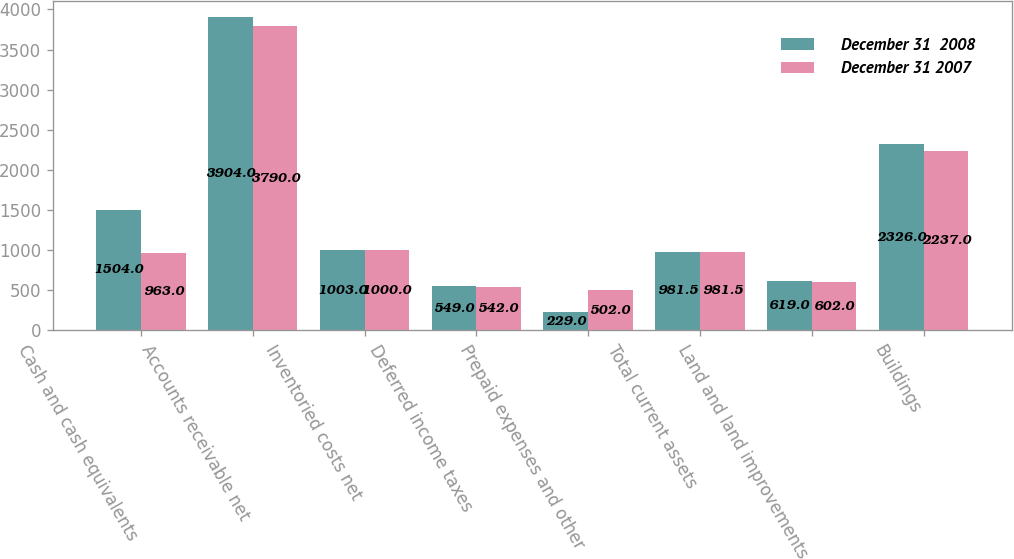Convert chart. <chart><loc_0><loc_0><loc_500><loc_500><stacked_bar_chart><ecel><fcel>Cash and cash equivalents<fcel>Accounts receivable net<fcel>Inventoried costs net<fcel>Deferred income taxes<fcel>Prepaid expenses and other<fcel>Total current assets<fcel>Land and land improvements<fcel>Buildings<nl><fcel>December 31  2008<fcel>1504<fcel>3904<fcel>1003<fcel>549<fcel>229<fcel>981.5<fcel>619<fcel>2326<nl><fcel>December 31 2007<fcel>963<fcel>3790<fcel>1000<fcel>542<fcel>502<fcel>981.5<fcel>602<fcel>2237<nl></chart> 